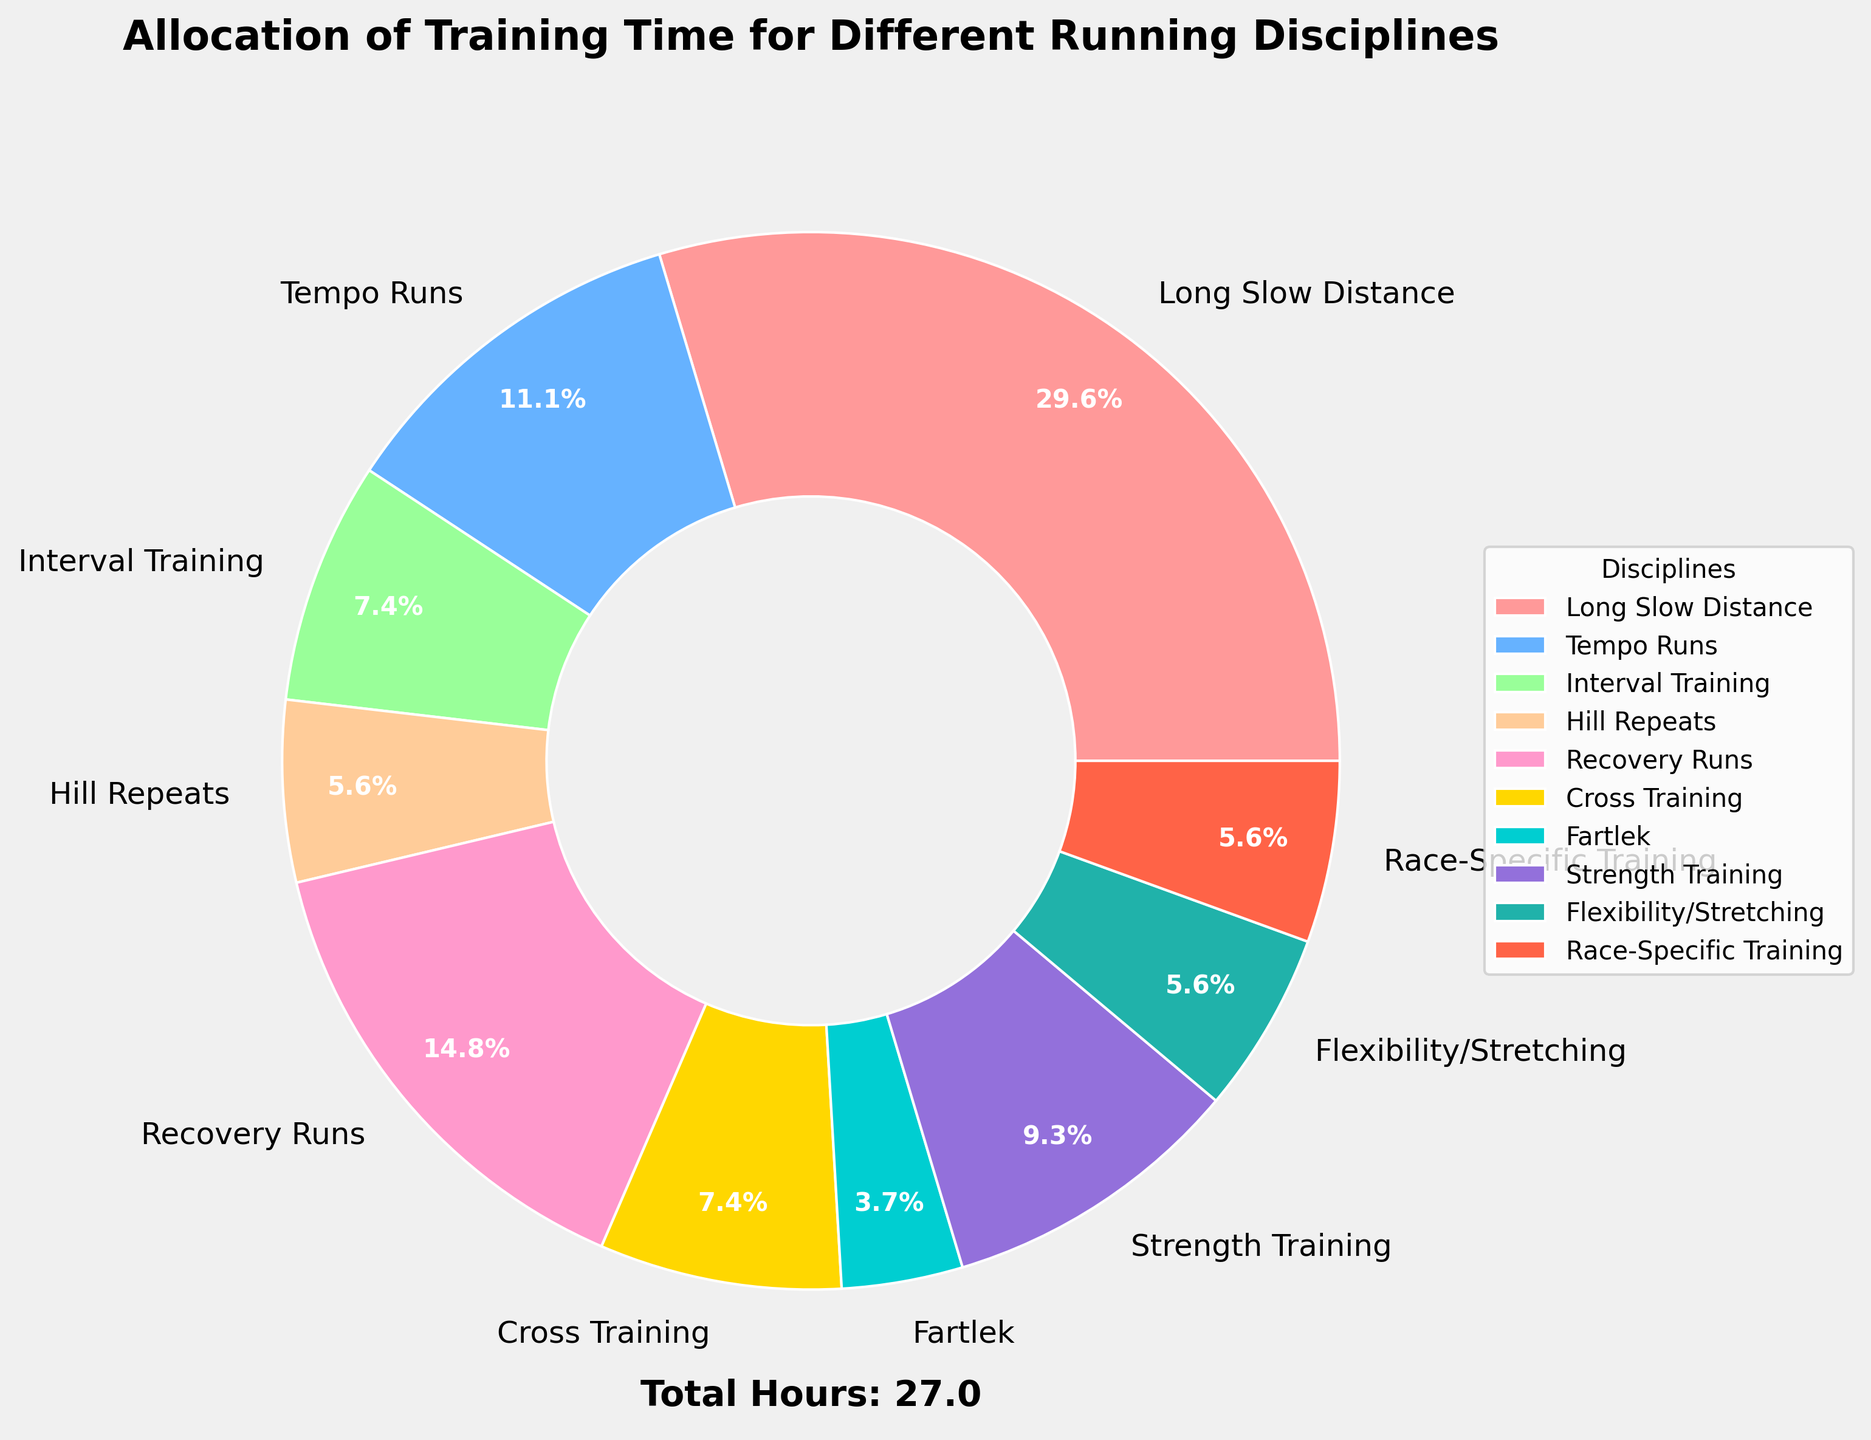What percentage of the week's training time is allocated to Long Slow Distance? By looking at the pie chart, identify the slice labeled "Long Slow Distance" and check the percentage value shown inside or near the wedge.
Answer: 40.0% Which discipline takes up the least training time? By examining each discipline in the pie chart, find the one with the smallest wedge and read the corresponding label.
Answer: Fartlek How many hours are spent on Recovery Runs and Cross Training combined? From the pie chart, find the hours for "Recovery Runs" and "Cross Training" and add them together: 4 (Recovery Runs) + 2 (Cross Training) = 6.
Answer: 6 hours Compare the time allocated to Strength Training relative to Flexibility/Stretching. Which one has more hours? Identify the wedges for "Strength Training" and "Flexibility/Stretching" and compare the hours indicated: 2.5 hours (Strength Training) vs. 1.5 hours (Flexibility/Stretching).
Answer: Strength Training What is the total amount of training time allocated to activities other than Long Slow Distance? Subtract the hours of Long Slow Distance from the total hours, which is provided below the chart. The total hours is 27, so 27 - 8 = 19 hours.
Answer: 19 hours What is the average time spent on Tempo Runs, Interval Training, and Hill Repeats? Sum the hours for these three disciplines and divide by the number of disciplines: (3 + 2 + 1.5) = 6.5, then divide by 3, resulting in an average of 2.17 hours.
Answer: 2.17 hours Which discipline has exactly the same training hours as Interval Training? Check the pie chart for the discipline that has the same numerical value as "Interval Training," which is 2 hours.
Answer: Cross Training Are Recovery Runs or Tempo Runs allocated more training time? Compare the hours shown for "Recovery Runs" and "Tempo Runs": 4 hours (Recovery Runs) vs. 3 hours (Tempo Runs).
Answer: Recovery Runs Which discipline is shown using a light green color? Locate the light green wedge in the pie chart and read the corresponding label.
Answer: Cross Training 